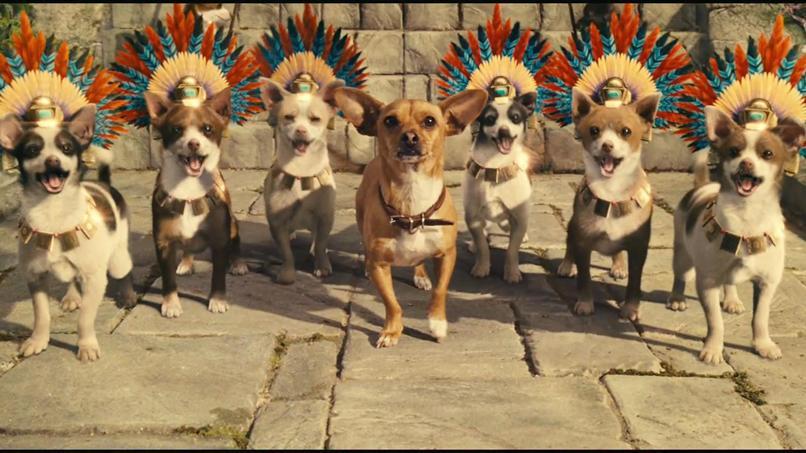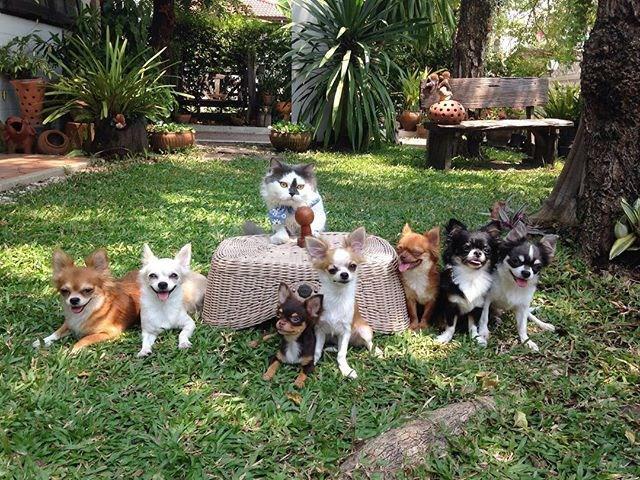The first image is the image on the left, the second image is the image on the right. Analyze the images presented: Is the assertion "In one image, seven small dogs and a large gray and white cat are in a shady grassy yard area with trees and shrubs." valid? Answer yes or no. Yes. 